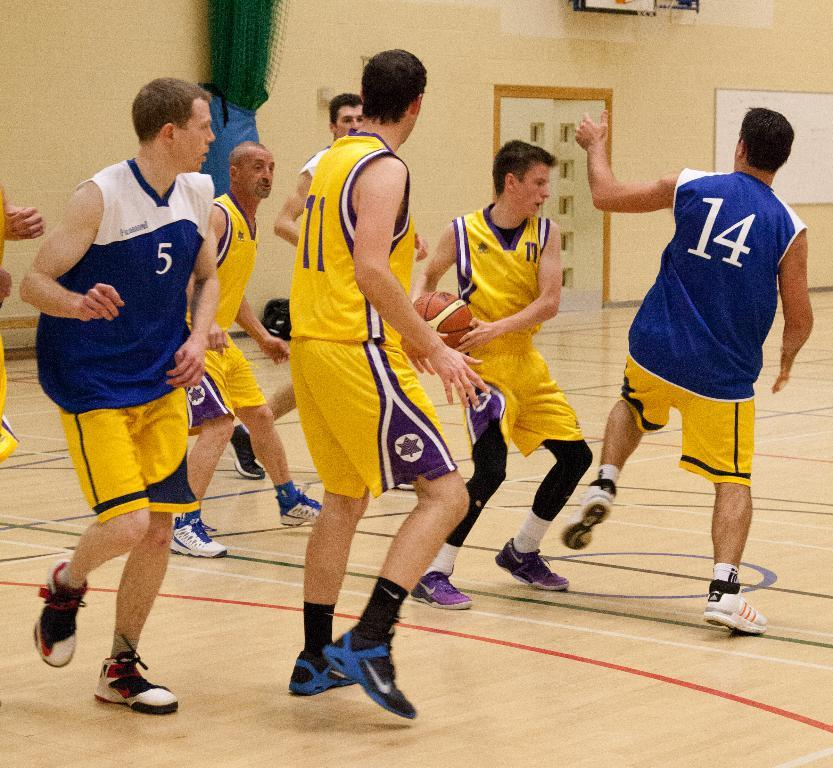Who or what can be seen in the image? There are people in the image. What are the people wearing? The people are wearing the same costume. What object is present in the image besides the people? There is a ball and a whiteboard in the image. What might the people be using the whiteboard for? The presence of the whiteboard suggests that it might be used for communication, instruction, or displaying information. Since the people are wearing the same costume, it is possible that they are part of a group or team activity. The ball could be related to a game or activity they are participating in. Absurd Question/Answer: What type of vessel can be seen sailing in the background of the image? There is no vessel or background visible in the image; it only shows people wearing costumes, a ball, and a whiteboard. 